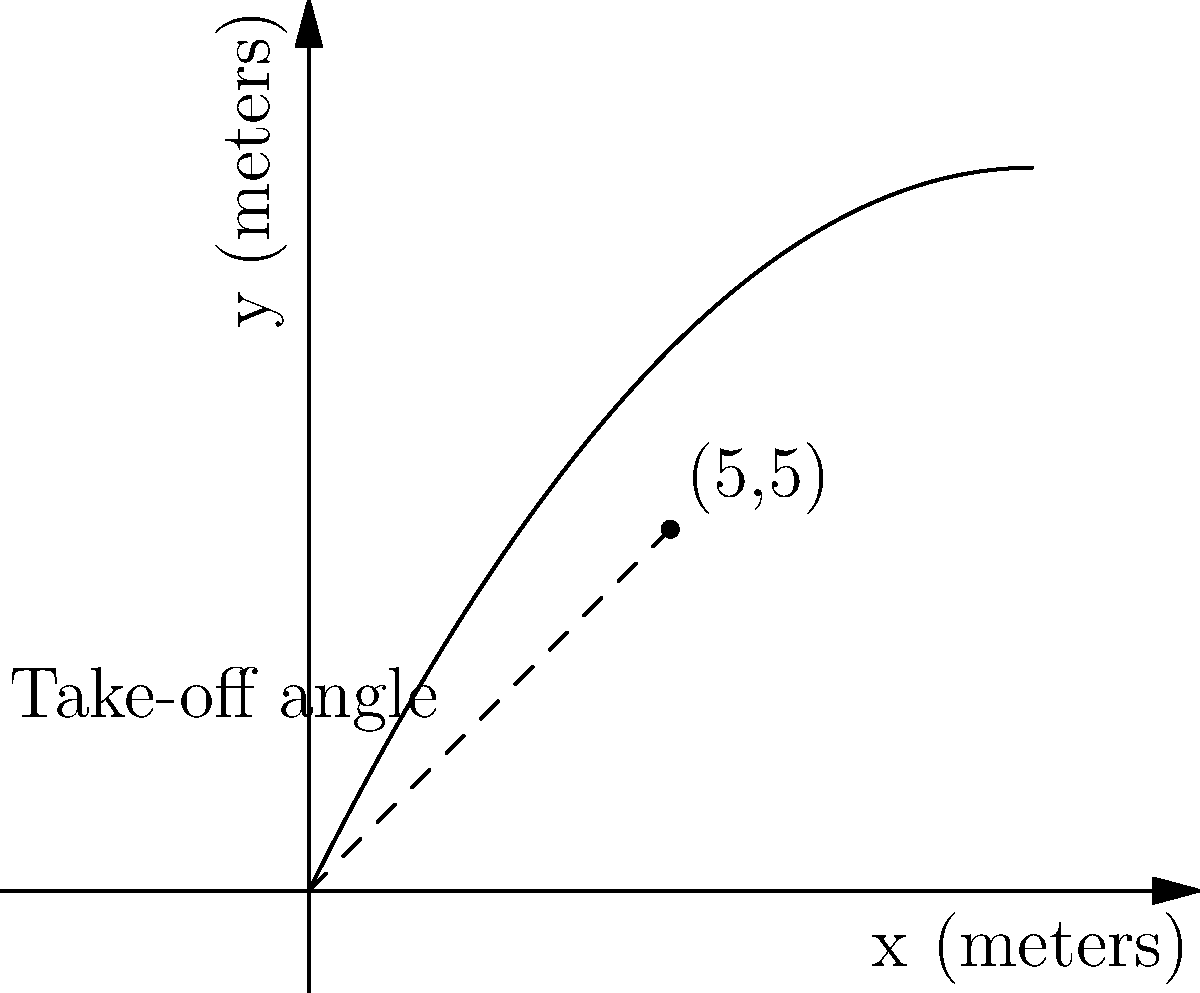A skier performs a jump that follows a parabolic trajectory described by the equation $y = -0.1x^2 + 2x$, where $x$ and $y$ are measured in meters. The skier reaches the highest point of the jump at (5, 5). What is the take-off angle of the ski jump in degrees? To find the take-off angle, we need to follow these steps:

1) The take-off angle is the angle between the x-axis and the tangent line to the parabola at the point (0, 0).

2) To find this angle, we need to calculate the slope of the tangent line at x = 0.

3) The slope of a tangent line is given by the derivative of the function at that point.

4) The function is $y = -0.1x^2 + 2x$

5) The derivative is $\frac{dy}{dx} = -0.2x + 2$

6) At x = 0, the slope is $-0.2(0) + 2 = 2$

7) The angle can be calculated using the arctangent function:
   $\theta = \arctan(2)$

8) Convert radians to degrees:
   $\theta = \arctan(2) \cdot \frac{180}{\pi} \approx 63.4°$

Therefore, the take-off angle is approximately 63.4°.
Answer: 63.4° 